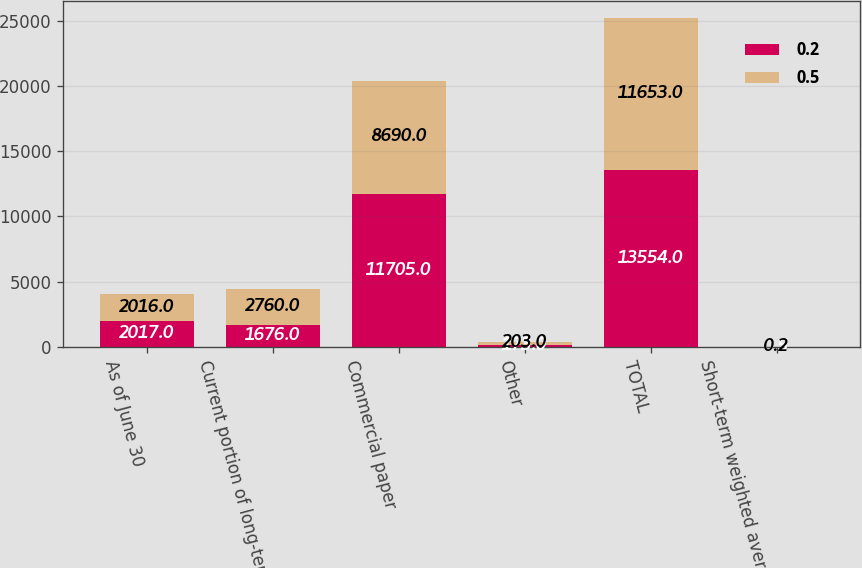Convert chart. <chart><loc_0><loc_0><loc_500><loc_500><stacked_bar_chart><ecel><fcel>As of June 30<fcel>Current portion of long-term<fcel>Commercial paper<fcel>Other<fcel>TOTAL<fcel>Short-term weighted average<nl><fcel>0.2<fcel>2017<fcel>1676<fcel>11705<fcel>173<fcel>13554<fcel>0.5<nl><fcel>0.5<fcel>2016<fcel>2760<fcel>8690<fcel>203<fcel>11653<fcel>0.2<nl></chart> 